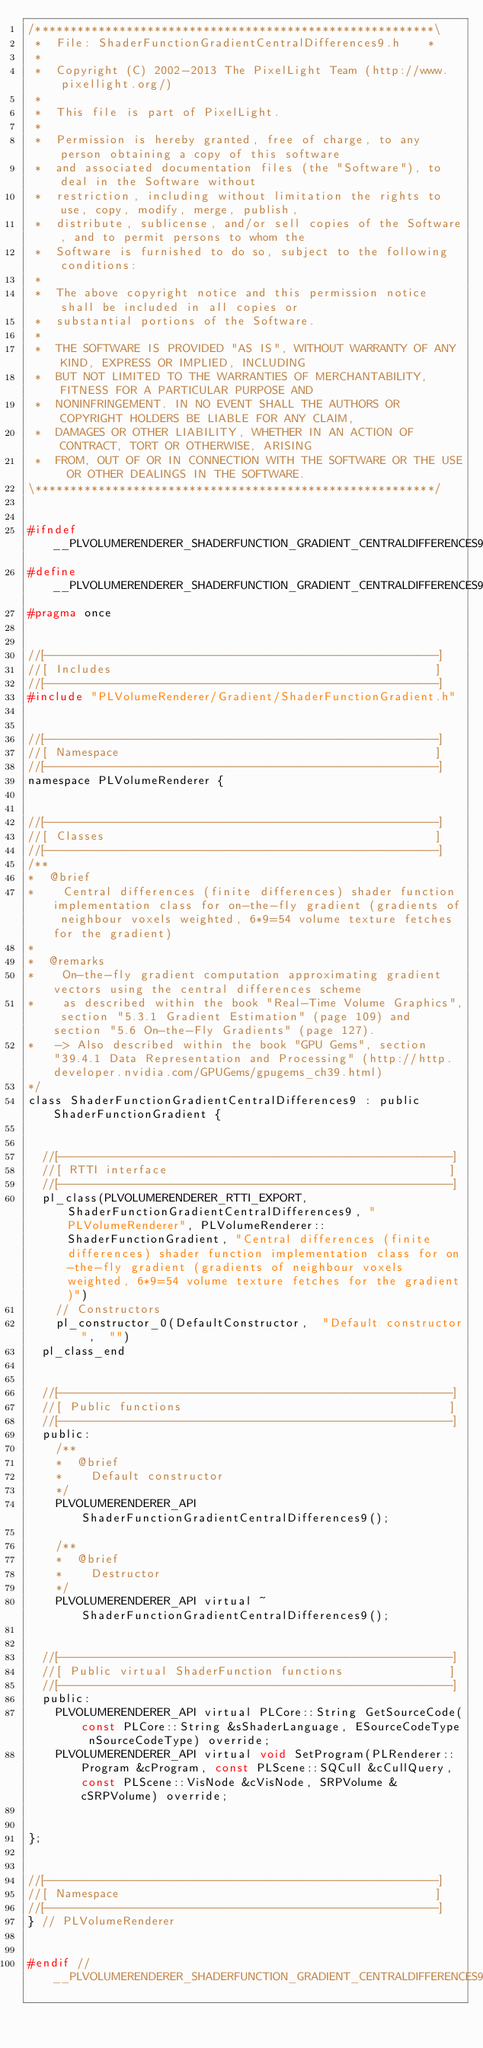<code> <loc_0><loc_0><loc_500><loc_500><_C_>/*********************************************************\
 *  File: ShaderFunctionGradientCentralDifferences9.h    *
 *
 *  Copyright (C) 2002-2013 The PixelLight Team (http://www.pixellight.org/)
 *
 *  This file is part of PixelLight.
 *
 *  Permission is hereby granted, free of charge, to any person obtaining a copy of this software
 *  and associated documentation files (the "Software"), to deal in the Software without
 *  restriction, including without limitation the rights to use, copy, modify, merge, publish,
 *  distribute, sublicense, and/or sell copies of the Software, and to permit persons to whom the
 *  Software is furnished to do so, subject to the following conditions:
 *
 *  The above copyright notice and this permission notice shall be included in all copies or
 *  substantial portions of the Software.
 *
 *  THE SOFTWARE IS PROVIDED "AS IS", WITHOUT WARRANTY OF ANY KIND, EXPRESS OR IMPLIED, INCLUDING
 *  BUT NOT LIMITED TO THE WARRANTIES OF MERCHANTABILITY, FITNESS FOR A PARTICULAR PURPOSE AND
 *  NONINFRINGEMENT. IN NO EVENT SHALL THE AUTHORS OR COPYRIGHT HOLDERS BE LIABLE FOR ANY CLAIM,
 *  DAMAGES OR OTHER LIABILITY, WHETHER IN AN ACTION OF CONTRACT, TORT OR OTHERWISE, ARISING
 *  FROM, OUT OF OR IN CONNECTION WITH THE SOFTWARE OR THE USE OR OTHER DEALINGS IN THE SOFTWARE.
\*********************************************************/


#ifndef __PLVOLUMERENDERER_SHADERFUNCTION_GRADIENT_CENTRALDIFFERENCES9_H__
#define __PLVOLUMERENDERER_SHADERFUNCTION_GRADIENT_CENTRALDIFFERENCES9_H__
#pragma once


//[-------------------------------------------------------]
//[ Includes                                              ]
//[-------------------------------------------------------]
#include "PLVolumeRenderer/Gradient/ShaderFunctionGradient.h"


//[-------------------------------------------------------]
//[ Namespace                                             ]
//[-------------------------------------------------------]
namespace PLVolumeRenderer {


//[-------------------------------------------------------]
//[ Classes                                               ]
//[-------------------------------------------------------]
/**
*  @brief
*    Central differences (finite differences) shader function implementation class for on-the-fly gradient (gradients of neighbour voxels weighted, 6*9=54 volume texture fetches for the gradient)
*
*  @remarks
*    On-the-fly gradient computation approximating gradient vectors using the central differences scheme
*    as described within the book "Real-Time Volume Graphics", section "5.3.1 Gradient Estimation" (page 109) and section "5.6 On-the-Fly Gradients" (page 127).
*   -> Also described within the book "GPU Gems", section "39.4.1 Data Representation and Processing" (http://http.developer.nvidia.com/GPUGems/gpugems_ch39.html)
*/
class ShaderFunctionGradientCentralDifferences9 : public ShaderFunctionGradient {


	//[-------------------------------------------------------]
	//[ RTTI interface                                        ]
	//[-------------------------------------------------------]
	pl_class(PLVOLUMERENDERER_RTTI_EXPORT, ShaderFunctionGradientCentralDifferences9, "PLVolumeRenderer", PLVolumeRenderer::ShaderFunctionGradient, "Central differences (finite differences) shader function implementation class for on-the-fly gradient (gradients of neighbour voxels weighted, 6*9=54 volume texture fetches for the gradient)")
		// Constructors
		pl_constructor_0(DefaultConstructor,	"Default constructor",	"")
	pl_class_end


	//[-------------------------------------------------------]
	//[ Public functions                                      ]
	//[-------------------------------------------------------]
	public:
		/**
		*  @brief
		*    Default constructor
		*/
		PLVOLUMERENDERER_API ShaderFunctionGradientCentralDifferences9();

		/**
		*  @brief
		*    Destructor
		*/
		PLVOLUMERENDERER_API virtual ~ShaderFunctionGradientCentralDifferences9();


	//[-------------------------------------------------------]
	//[ Public virtual ShaderFunction functions               ]
	//[-------------------------------------------------------]
	public:
		PLVOLUMERENDERER_API virtual PLCore::String GetSourceCode(const PLCore::String &sShaderLanguage, ESourceCodeType nSourceCodeType) override;
		PLVOLUMERENDERER_API virtual void SetProgram(PLRenderer::Program &cProgram, const PLScene::SQCull &cCullQuery, const PLScene::VisNode &cVisNode, SRPVolume &cSRPVolume) override;


};


//[-------------------------------------------------------]
//[ Namespace                                             ]
//[-------------------------------------------------------]
} // PLVolumeRenderer


#endif // __PLVOLUMERENDERER_SHADERFUNCTION_GRADIENT_CENTRALDIFFERENCES9_H__
</code> 